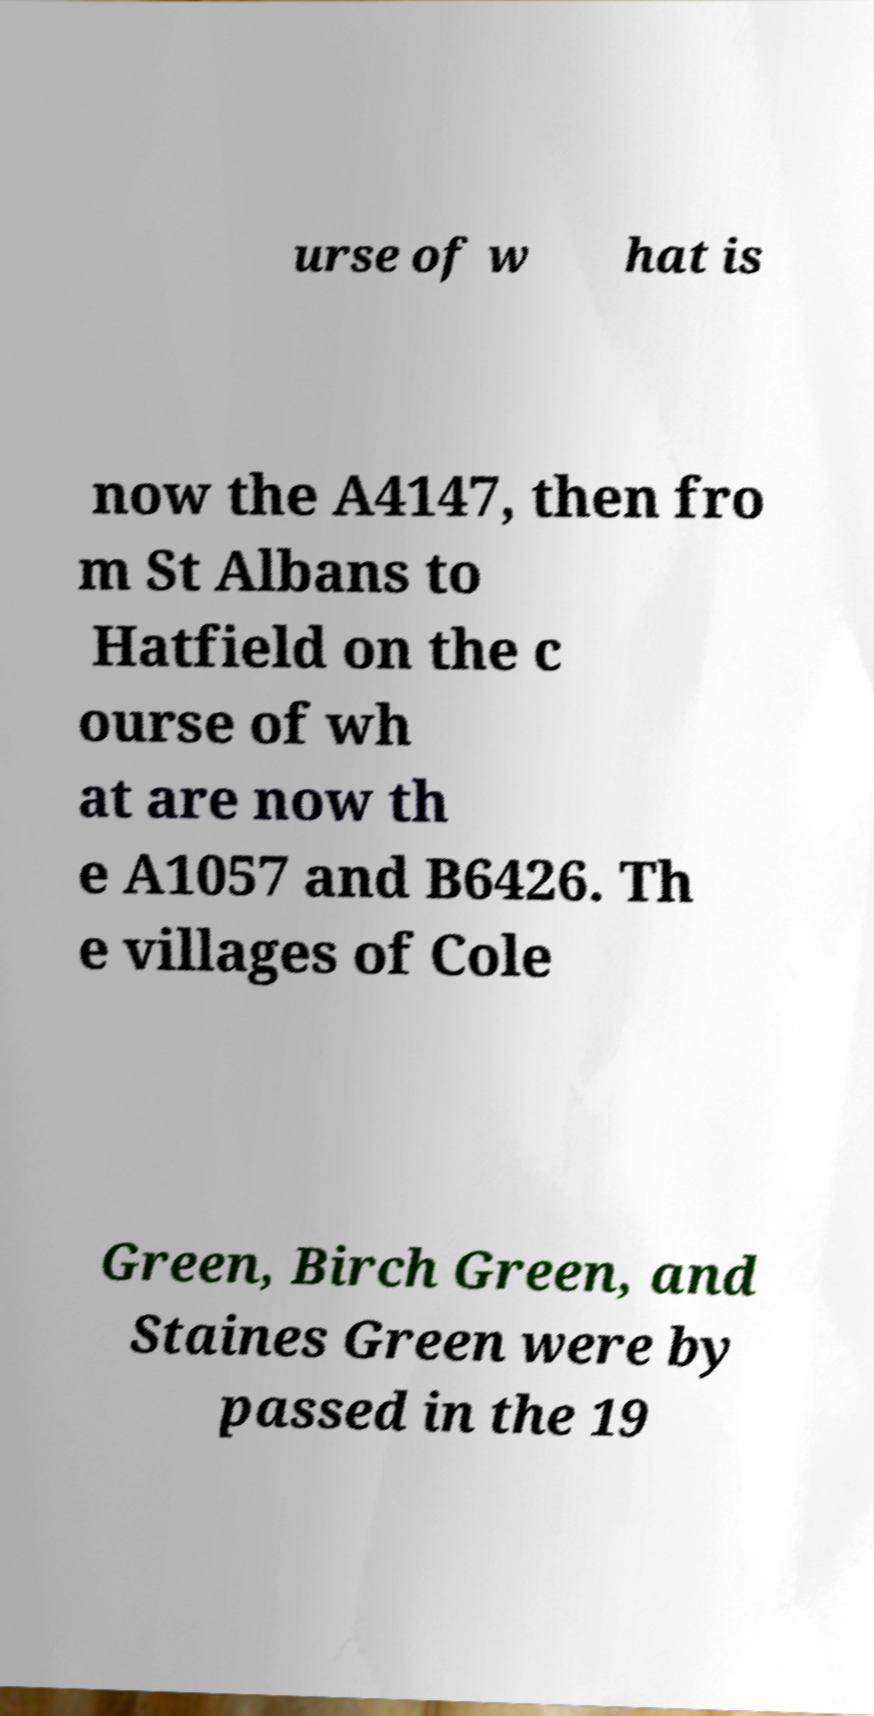For documentation purposes, I need the text within this image transcribed. Could you provide that? urse of w hat is now the A4147, then fro m St Albans to Hatfield on the c ourse of wh at are now th e A1057 and B6426. Th e villages of Cole Green, Birch Green, and Staines Green were by passed in the 19 